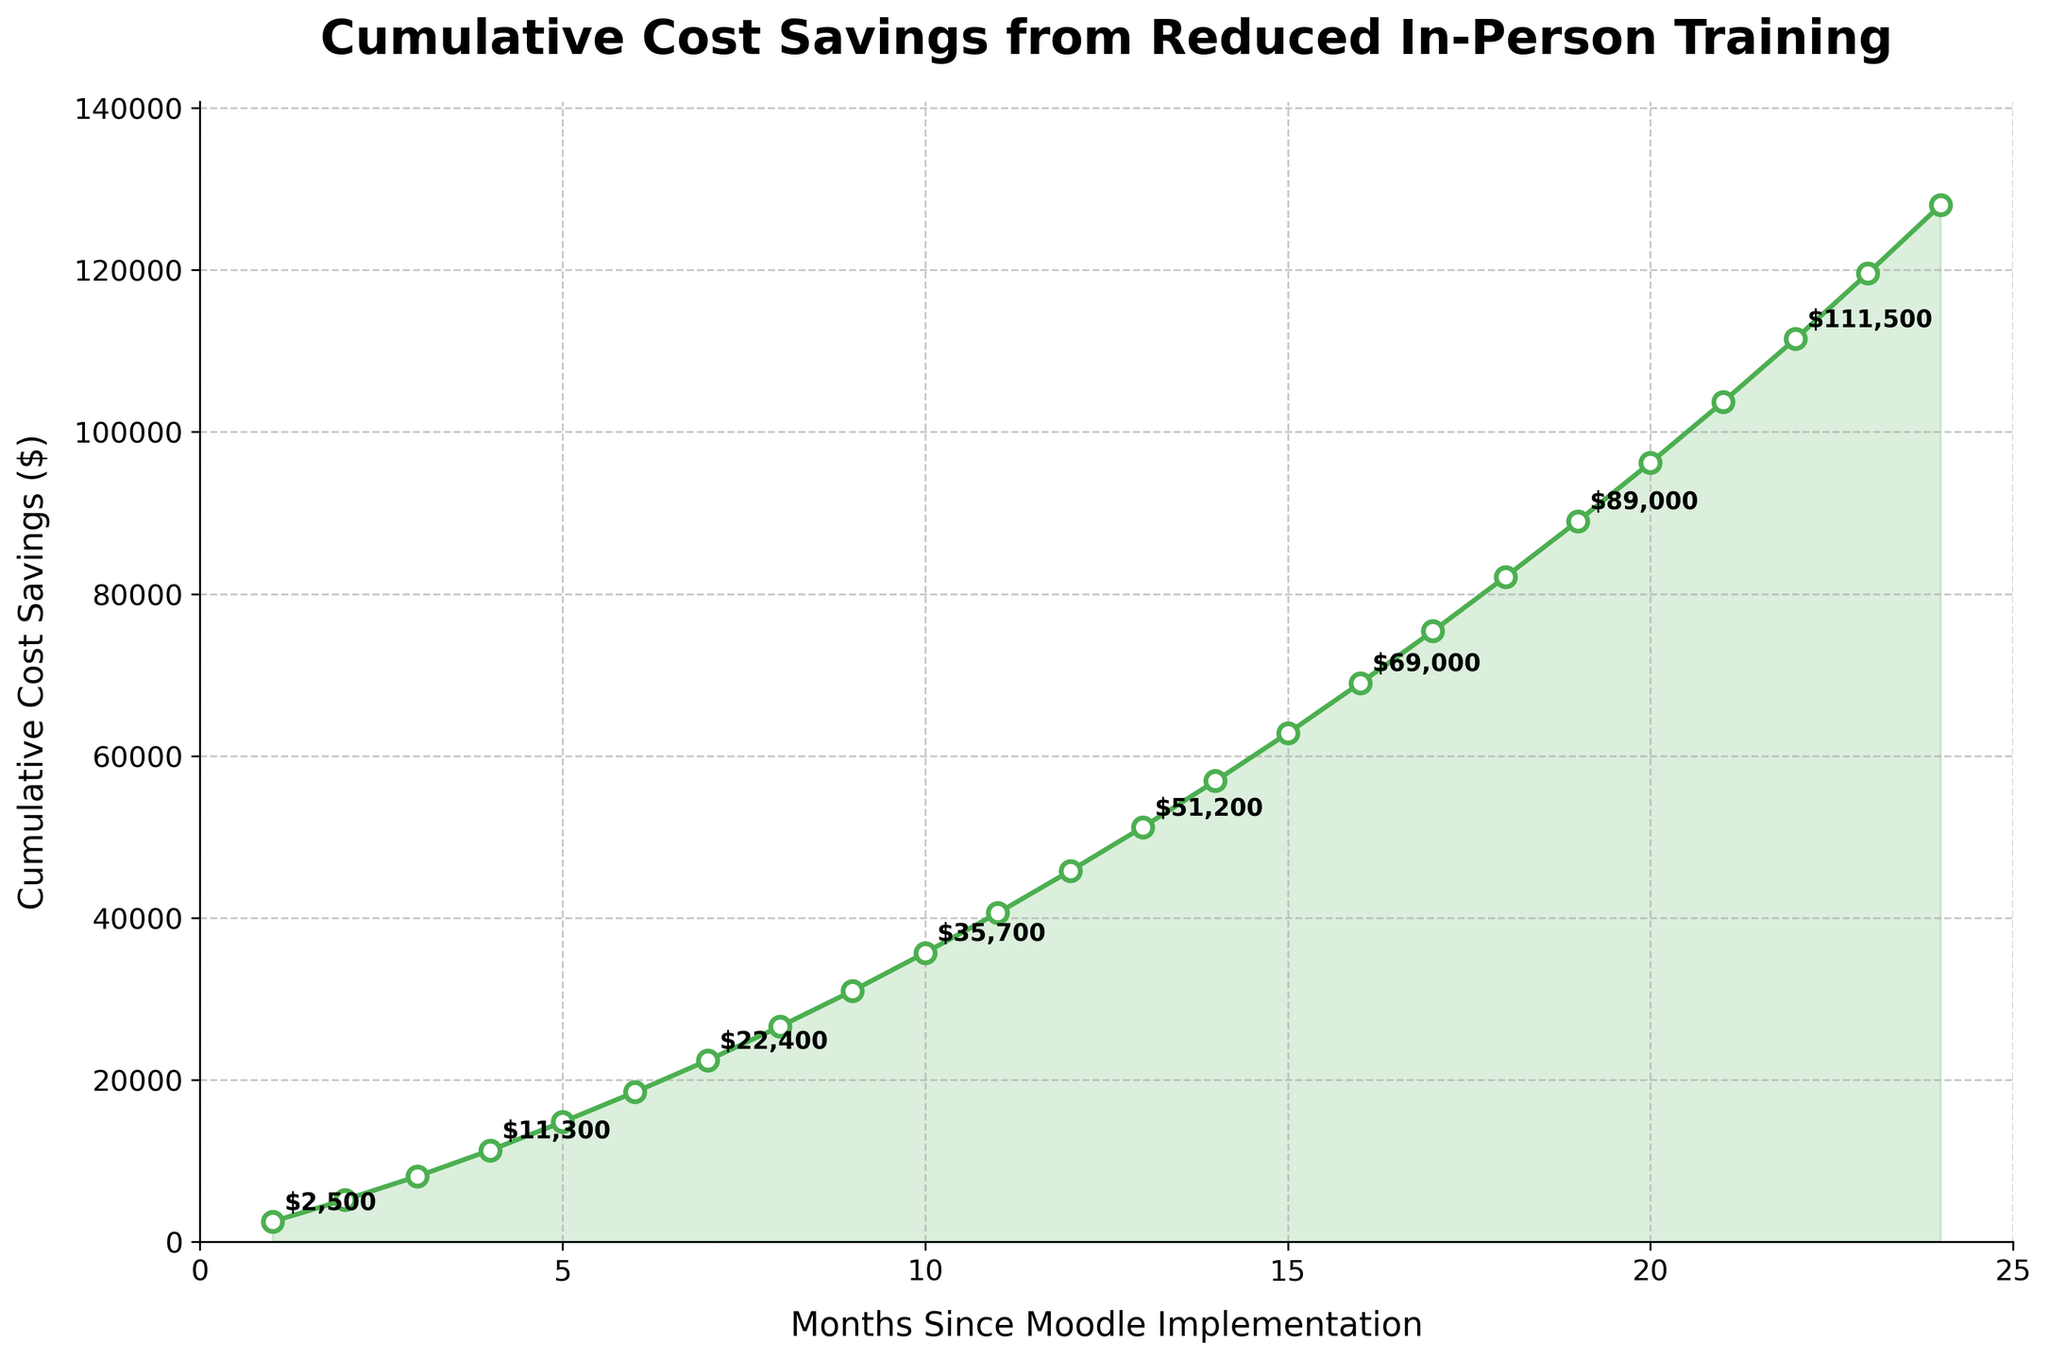What's the cumulative cost savings at 12 months? To determine the cumulative cost savings at 12 months, refer to the data point directly corresponding to month 12 on the line chart. The y-axis value at this point represents the cumulative cost savings.
Answer: $45,800 Between which two months does the cumulative cost savings increase the most? To find the month interval with the highest increase in cost savings, calculate the differences between consecutive data points. The largest difference indicates the greatest increase. Here, the highest increase (8,900) occurs between months 20 ($96,200) and 21 ($103,700).
Answer: Between months 20 and 21 Is the increase in cumulative cost savings more consistent in the first year or the second year? By visually inspecting the intervals between points in the first year (months 1-12) and the second year (months 13-24), notice that the line in both years has a generally steady upward trend. However, slightly larger jumps in savings occur in the second year.
Answer: First year What is the cumulative cost savings after 18 months? Look at the data point for the 18th month on the line chart and note the corresponding y-axis value. This indicates the cumulative cost savings after 18 months.
Answer: $82,100 How does the cumulative cost savings at month 24 compare to month 12? To compare the cumulative cost savings at these two months, find their respective values. Month 12 has $45,800, and month 24 has $128,000. Subtract month 12 from month 24 to find the difference.
Answer: $82,200 higher What is the colored fill under the line graph indicating? The colored fill under the line graph visually represents the area that accumulates the total cost savings over time, emphasizing the overall upward trend.
Answer: Area under the curve represents cumulative savings What pattern can you observe in the data annotations provided every third month? By examining the data annotations provided every third month, notice that they show an increasing trend with values spaced relatively evenly, demonstrating steady cumulative savings growth.
Answer: Steadily increasing cumulative savings How much are the cost savings in the month right after the initial implementation (second month)? Find the cumulative cost savings for the second month from the chart, indicated by the second data point on the graph.
Answer: $5,200 What is the approximate average monthly cost savings growth in the first six months? To find the approximate average, calculate the total increase in savings over the first six months and divide it by six. The savings go from $2,500 to $18,500, resulting in an increase of $16,000 over six months. Dividing $16,000 by 6 gives the average monthly growth.
Answer: $2,667 By how much did the savings increase between months 4 and 10? Determine the cumulative savings at both months, $11,300 at month 4 and $35,700 at month 10, respectively. Subtract the savings at month 4 from the savings at month 10.
Answer: $24,400 